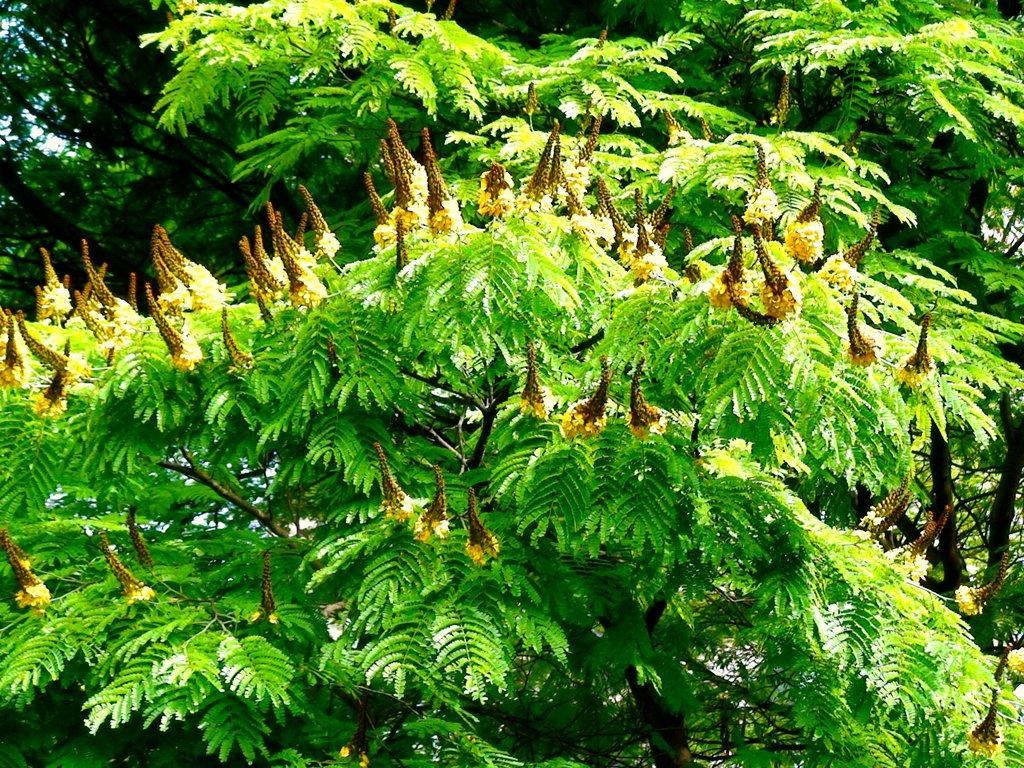What type of vegetation is present in the image? There are trees with leaves in the image. What color are the flowers in the image? The flowers in the image are yellow. What is the limit of the scissors in the image? There are no scissors present in the image. How many fingers can be seen interacting with the flowers in the image? There are no fingers or hands visible in the image; only the trees, leaves, and flowers are present. 